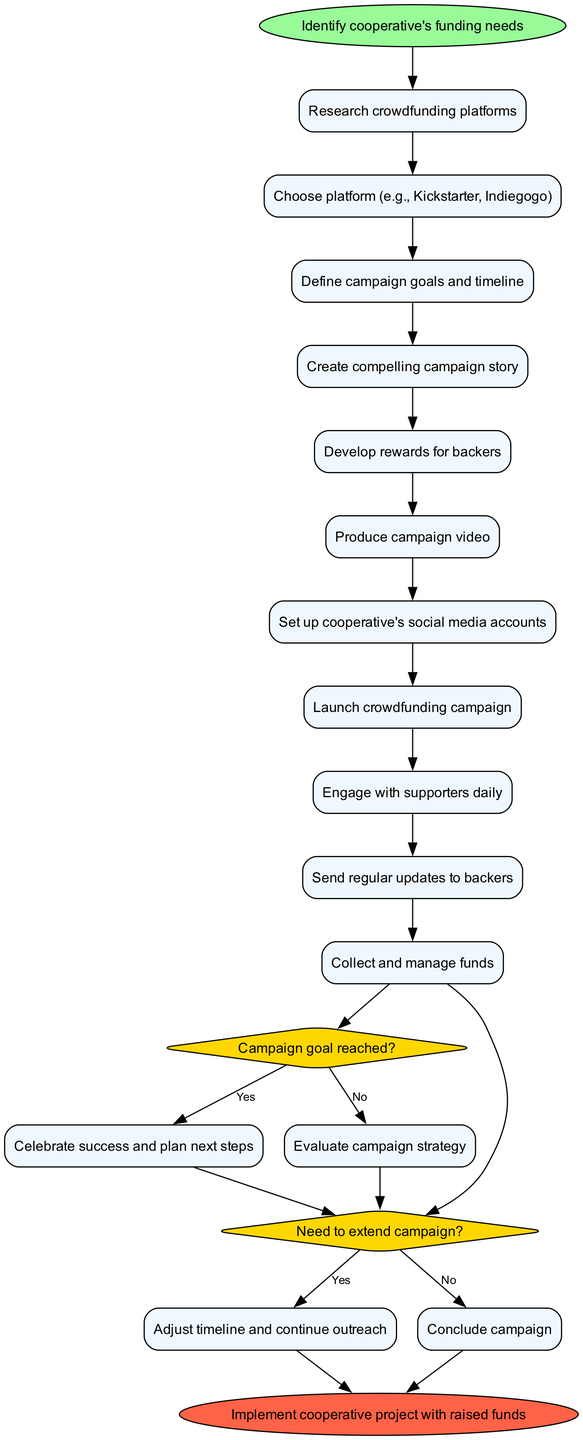What is the first activity in the diagram? The first activity is directly connected to the start node, which is "Identify cooperative's funding needs."
Answer: Identify cooperative's funding needs How many activities are listed in the diagram? Counting all the activities from the activities section, there are 11 activities, including the initial activity.
Answer: 11 What decision follows the last activity? The last activity, "Produce campaign video," leads to the decision question, "Campaign goal reached?"
Answer: Campaign goal reached? What is the outcome if the campaign goal is reached? Following the "Campaign goal reached?" decision, the "Yes" branch leads to "Celebrate success and plan next steps."
Answer: Celebrate success and plan next steps What happens if there is a need to extend the campaign? If the "Need to extend campaign?" decision results in "Yes," it leads to "Adjust timeline and continue outreach."
Answer: Adjust timeline and continue outreach How many outcomes are there from the final decision? The final decision "Need to extend campaign?" results in two outcomes, "Yes" and "No" leading to different actions.
Answer: 2 What is the last step in the process when the funds are successfully raised? At the end of the activity diagram, after following the successful route through the decisions, the final step is "Implement cooperative project with raised funds."
Answer: Implement cooperative project with raised funds What connects the start node to the activities? Each activity is connected sequentially, starting from the start node and branching out to the activities.
Answer: Activities Which decision primarily evaluates the success of the crowdfunding campaign? The decision titled "Campaign goal reached?" evaluates whether the campaign has been successful based on its goal.
Answer: Campaign goal reached? What is the final node in the diagram? The final node is the endpoint of the process, which is "Implement cooperative project with raised funds."
Answer: Implement cooperative project with raised funds 